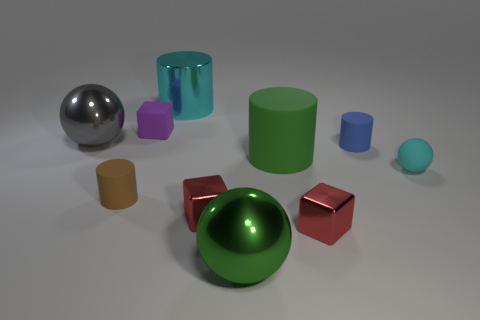Subtract all cylinders. How many objects are left? 6 Subtract 0 brown blocks. How many objects are left? 10 Subtract all cyan matte cylinders. Subtract all purple rubber cubes. How many objects are left? 9 Add 6 small red metallic objects. How many small red metallic objects are left? 8 Add 5 balls. How many balls exist? 8 